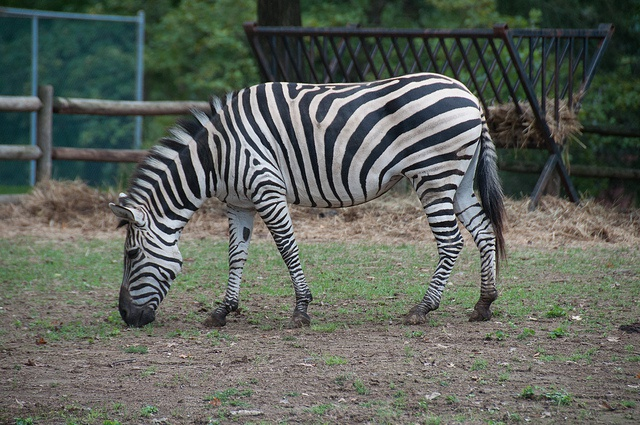Describe the objects in this image and their specific colors. I can see a zebra in black, darkgray, gray, and lightgray tones in this image. 